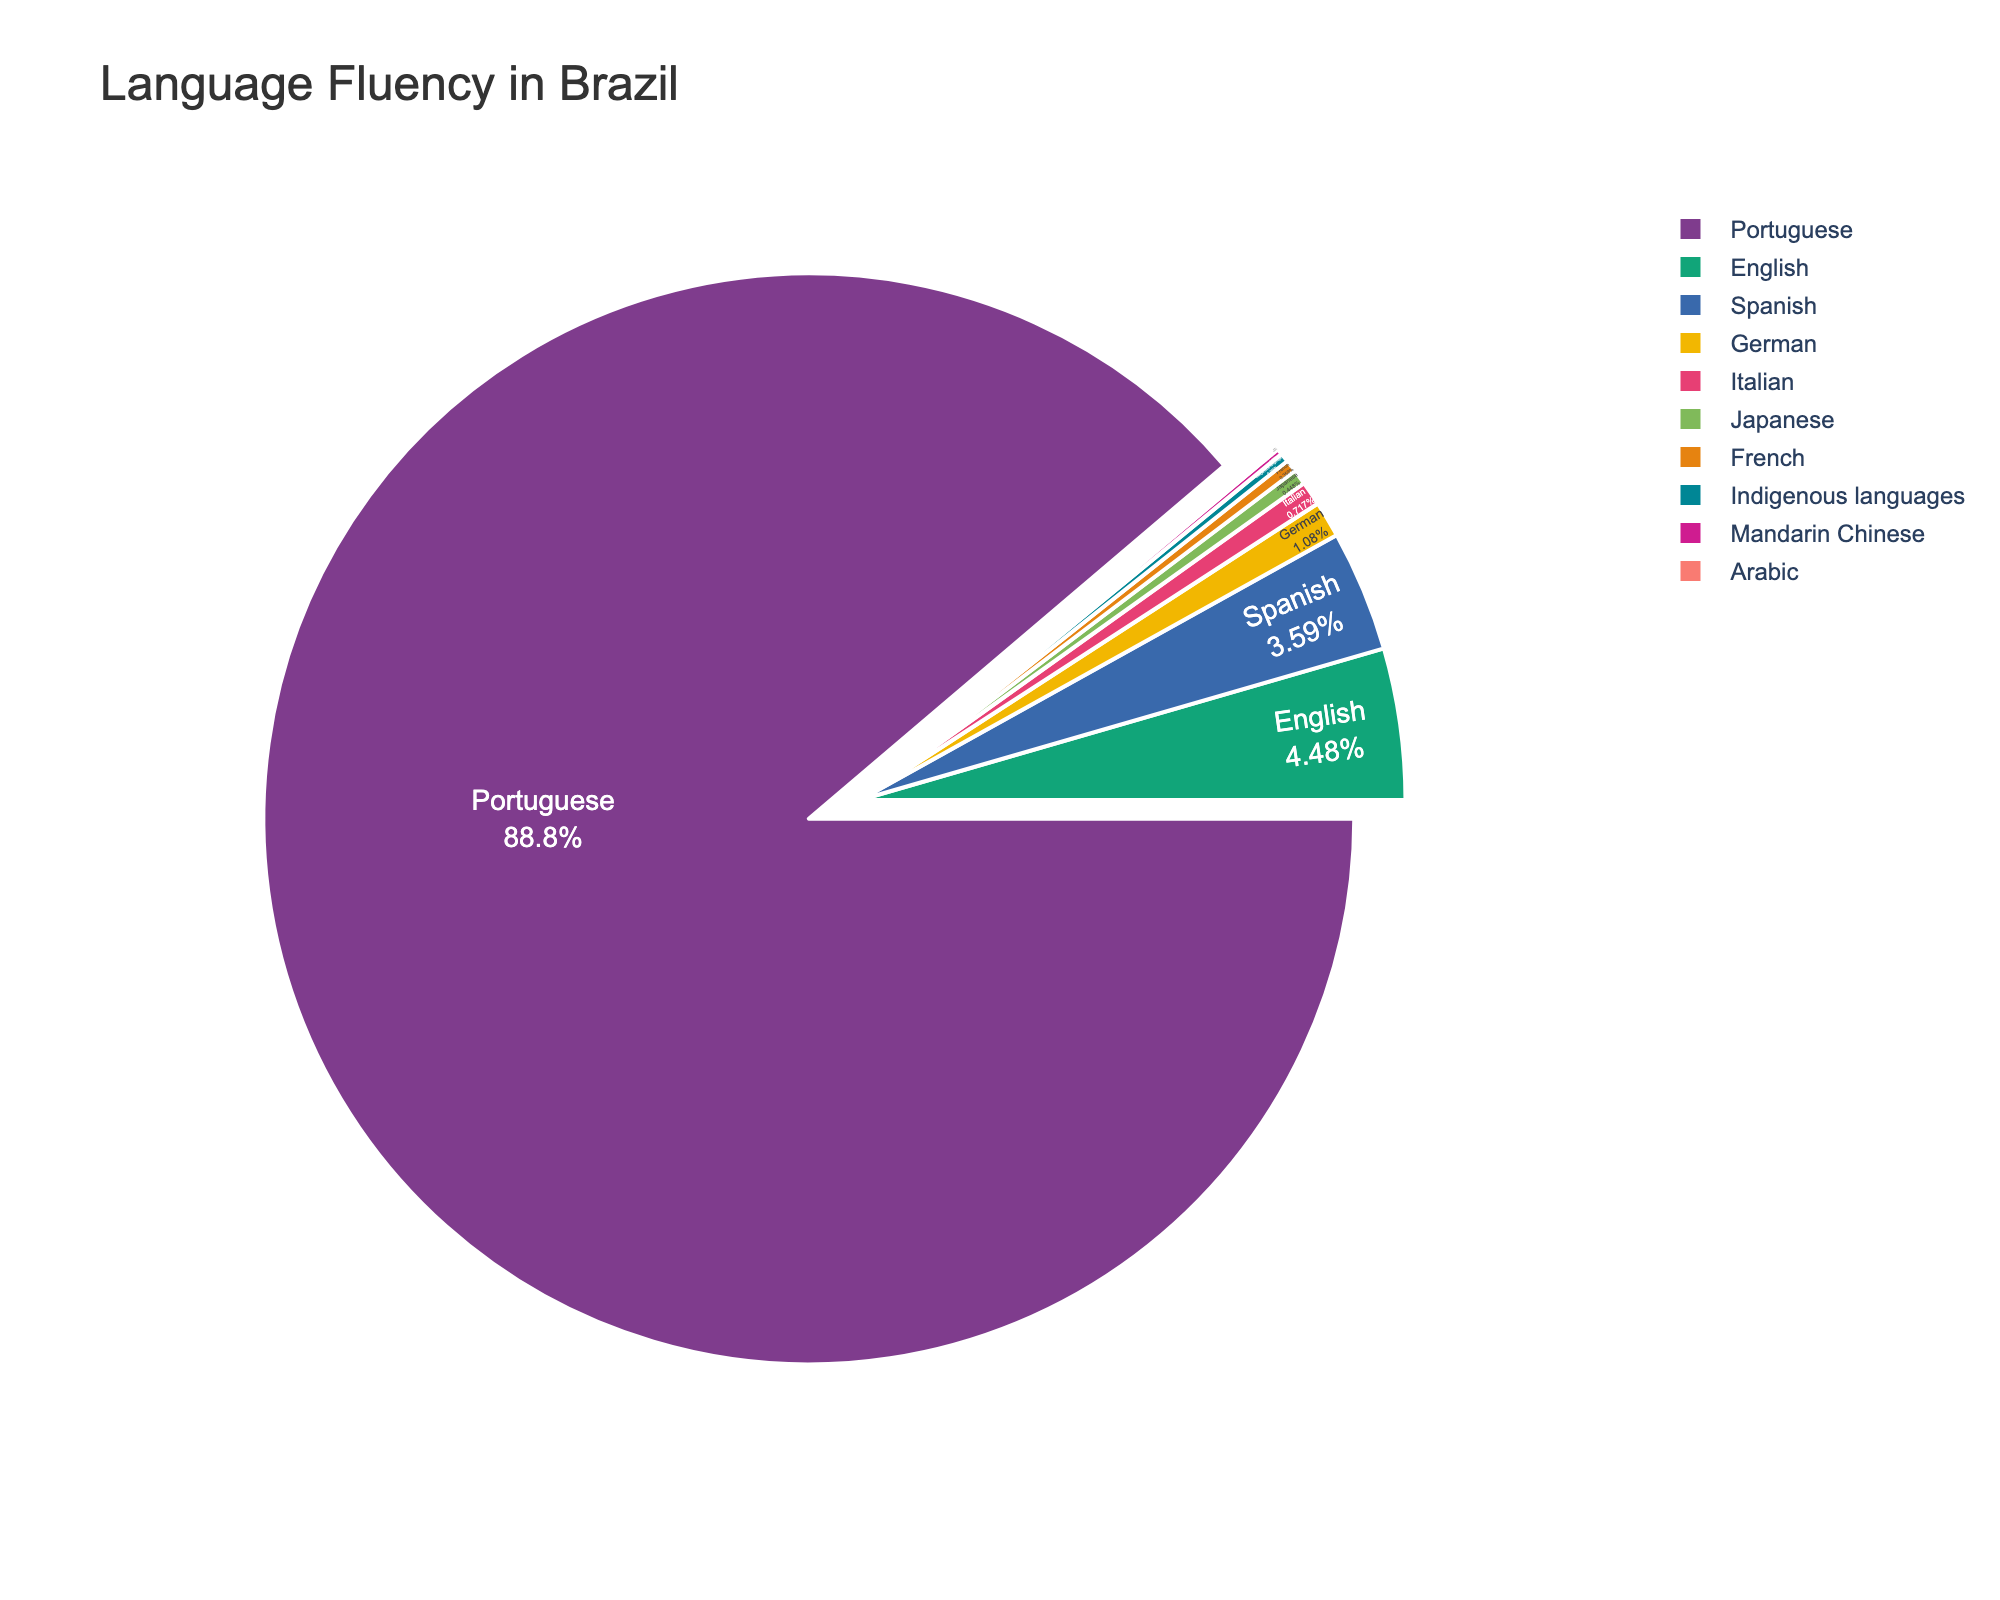What's the dominant language spoken in Brazil according to the chart? The largest section of the pie chart represents Portuguese, indicating it is the most widely spoken language in Brazil, occupying 99% of the population.
Answer: Portuguese How does the fluency in Spanish compare to that in English in Brazil? By comparing the slices of the pie chart, Spanish fluency comprises 4% of the population while English fluency is slightly higher at 5%.
Answer: English is higher What visual techniques are used to emphasize the most dominant language in the chart? The Portuguese section is pulled out from the pie chart more than any other slice, making it visually prominent. Additionally, it occupies the majority of the chart area.
Answer: Pulling out the slice and majority area occupied Which two languages have the closest percentages of speakers in Brazil? German and Italian have percentages of 1.2% and 0.8% respectively, making them the closest in terms of percentage among all listed languages.
Answer: German and Italian What is the total percentage of the Brazilian population fluent in either Japanese or French? Sum the percentages of Japanese and French: 0.5% + 0.4% = 0.9%.
Answer: 0.9% Between Mandarin Chinese and Indigenous languages, which has more speakers and by what percentage? Indigenous languages have 0.3%, while Mandarin Chinese has 0.2%. The difference is 0.3% - 0.2% = 0.1%.
Answer: Indigenous languages by 0.1% How many languages listed are spoken by less than 1% of Brazil's population? By examining the chart, Italian (0.8%), Japanese (0.5%), French (0.4%), Indigenous languages (0.3%), Mandarin Chinese (0.2%), and Arabic (0.1%) are all spoken by less than 1% of the population, adding up to 6 languages.
Answer: 6 languages What's the combined percentage of the population fluent in German and Italian? Sum the percentages: 1.2% for German and 0.8% for Italian, giving 1.2% + 0.8% = 2%.
Answer: 2% Which language has fewer speakers than Japanese but more speakers than Mandarin Chinese? French, with a percentage of 0.4%, fits this criterion as it lies between Japanese (0.5%) and Mandarin Chinese (0.2%).
Answer: French 